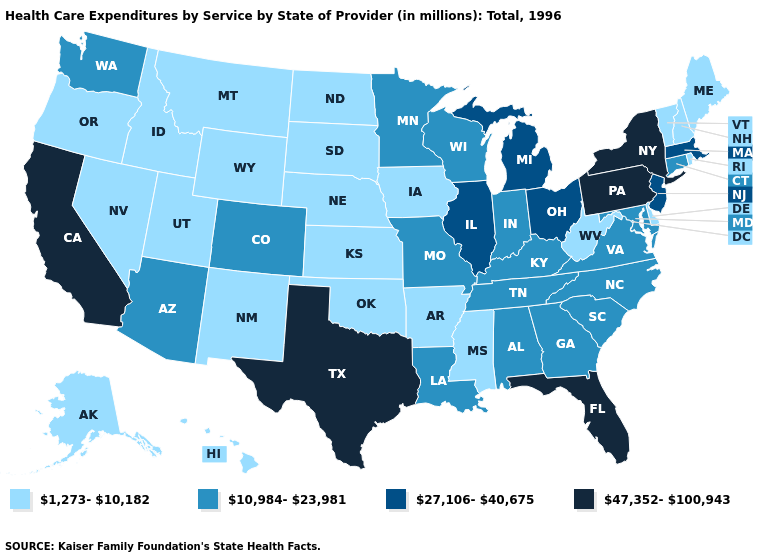Which states hav the highest value in the MidWest?
Write a very short answer. Illinois, Michigan, Ohio. What is the value of Indiana?
Answer briefly. 10,984-23,981. Name the states that have a value in the range 1,273-10,182?
Keep it brief. Alaska, Arkansas, Delaware, Hawaii, Idaho, Iowa, Kansas, Maine, Mississippi, Montana, Nebraska, Nevada, New Hampshire, New Mexico, North Dakota, Oklahoma, Oregon, Rhode Island, South Dakota, Utah, Vermont, West Virginia, Wyoming. What is the value of Louisiana?
Give a very brief answer. 10,984-23,981. Name the states that have a value in the range 47,352-100,943?
Keep it brief. California, Florida, New York, Pennsylvania, Texas. Which states have the lowest value in the Northeast?
Be succinct. Maine, New Hampshire, Rhode Island, Vermont. Which states have the lowest value in the USA?
Short answer required. Alaska, Arkansas, Delaware, Hawaii, Idaho, Iowa, Kansas, Maine, Mississippi, Montana, Nebraska, Nevada, New Hampshire, New Mexico, North Dakota, Oklahoma, Oregon, Rhode Island, South Dakota, Utah, Vermont, West Virginia, Wyoming. What is the value of California?
Concise answer only. 47,352-100,943. Is the legend a continuous bar?
Answer briefly. No. Name the states that have a value in the range 47,352-100,943?
Answer briefly. California, Florida, New York, Pennsylvania, Texas. Name the states that have a value in the range 27,106-40,675?
Write a very short answer. Illinois, Massachusetts, Michigan, New Jersey, Ohio. How many symbols are there in the legend?
Quick response, please. 4. Which states hav the highest value in the South?
Concise answer only. Florida, Texas. How many symbols are there in the legend?
Answer briefly. 4. Does the first symbol in the legend represent the smallest category?
Short answer required. Yes. 